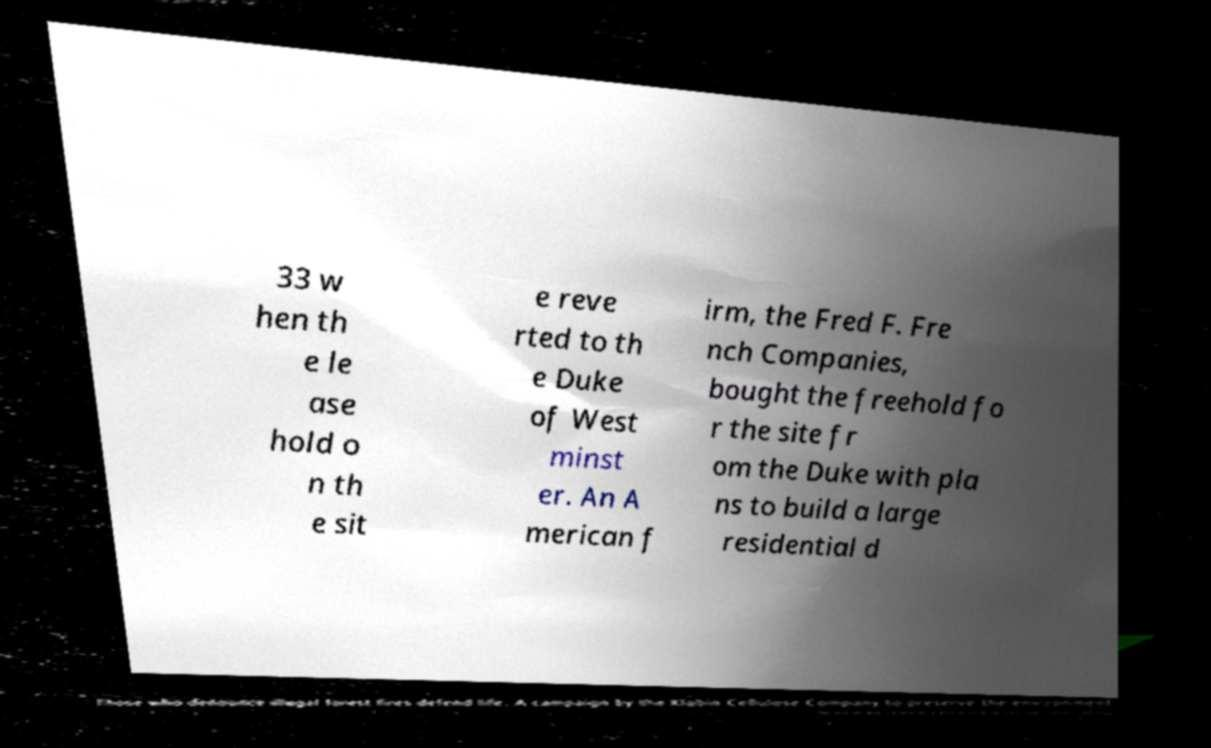Please read and relay the text visible in this image. What does it say? 33 w hen th e le ase hold o n th e sit e reve rted to th e Duke of West minst er. An A merican f irm, the Fred F. Fre nch Companies, bought the freehold fo r the site fr om the Duke with pla ns to build a large residential d 